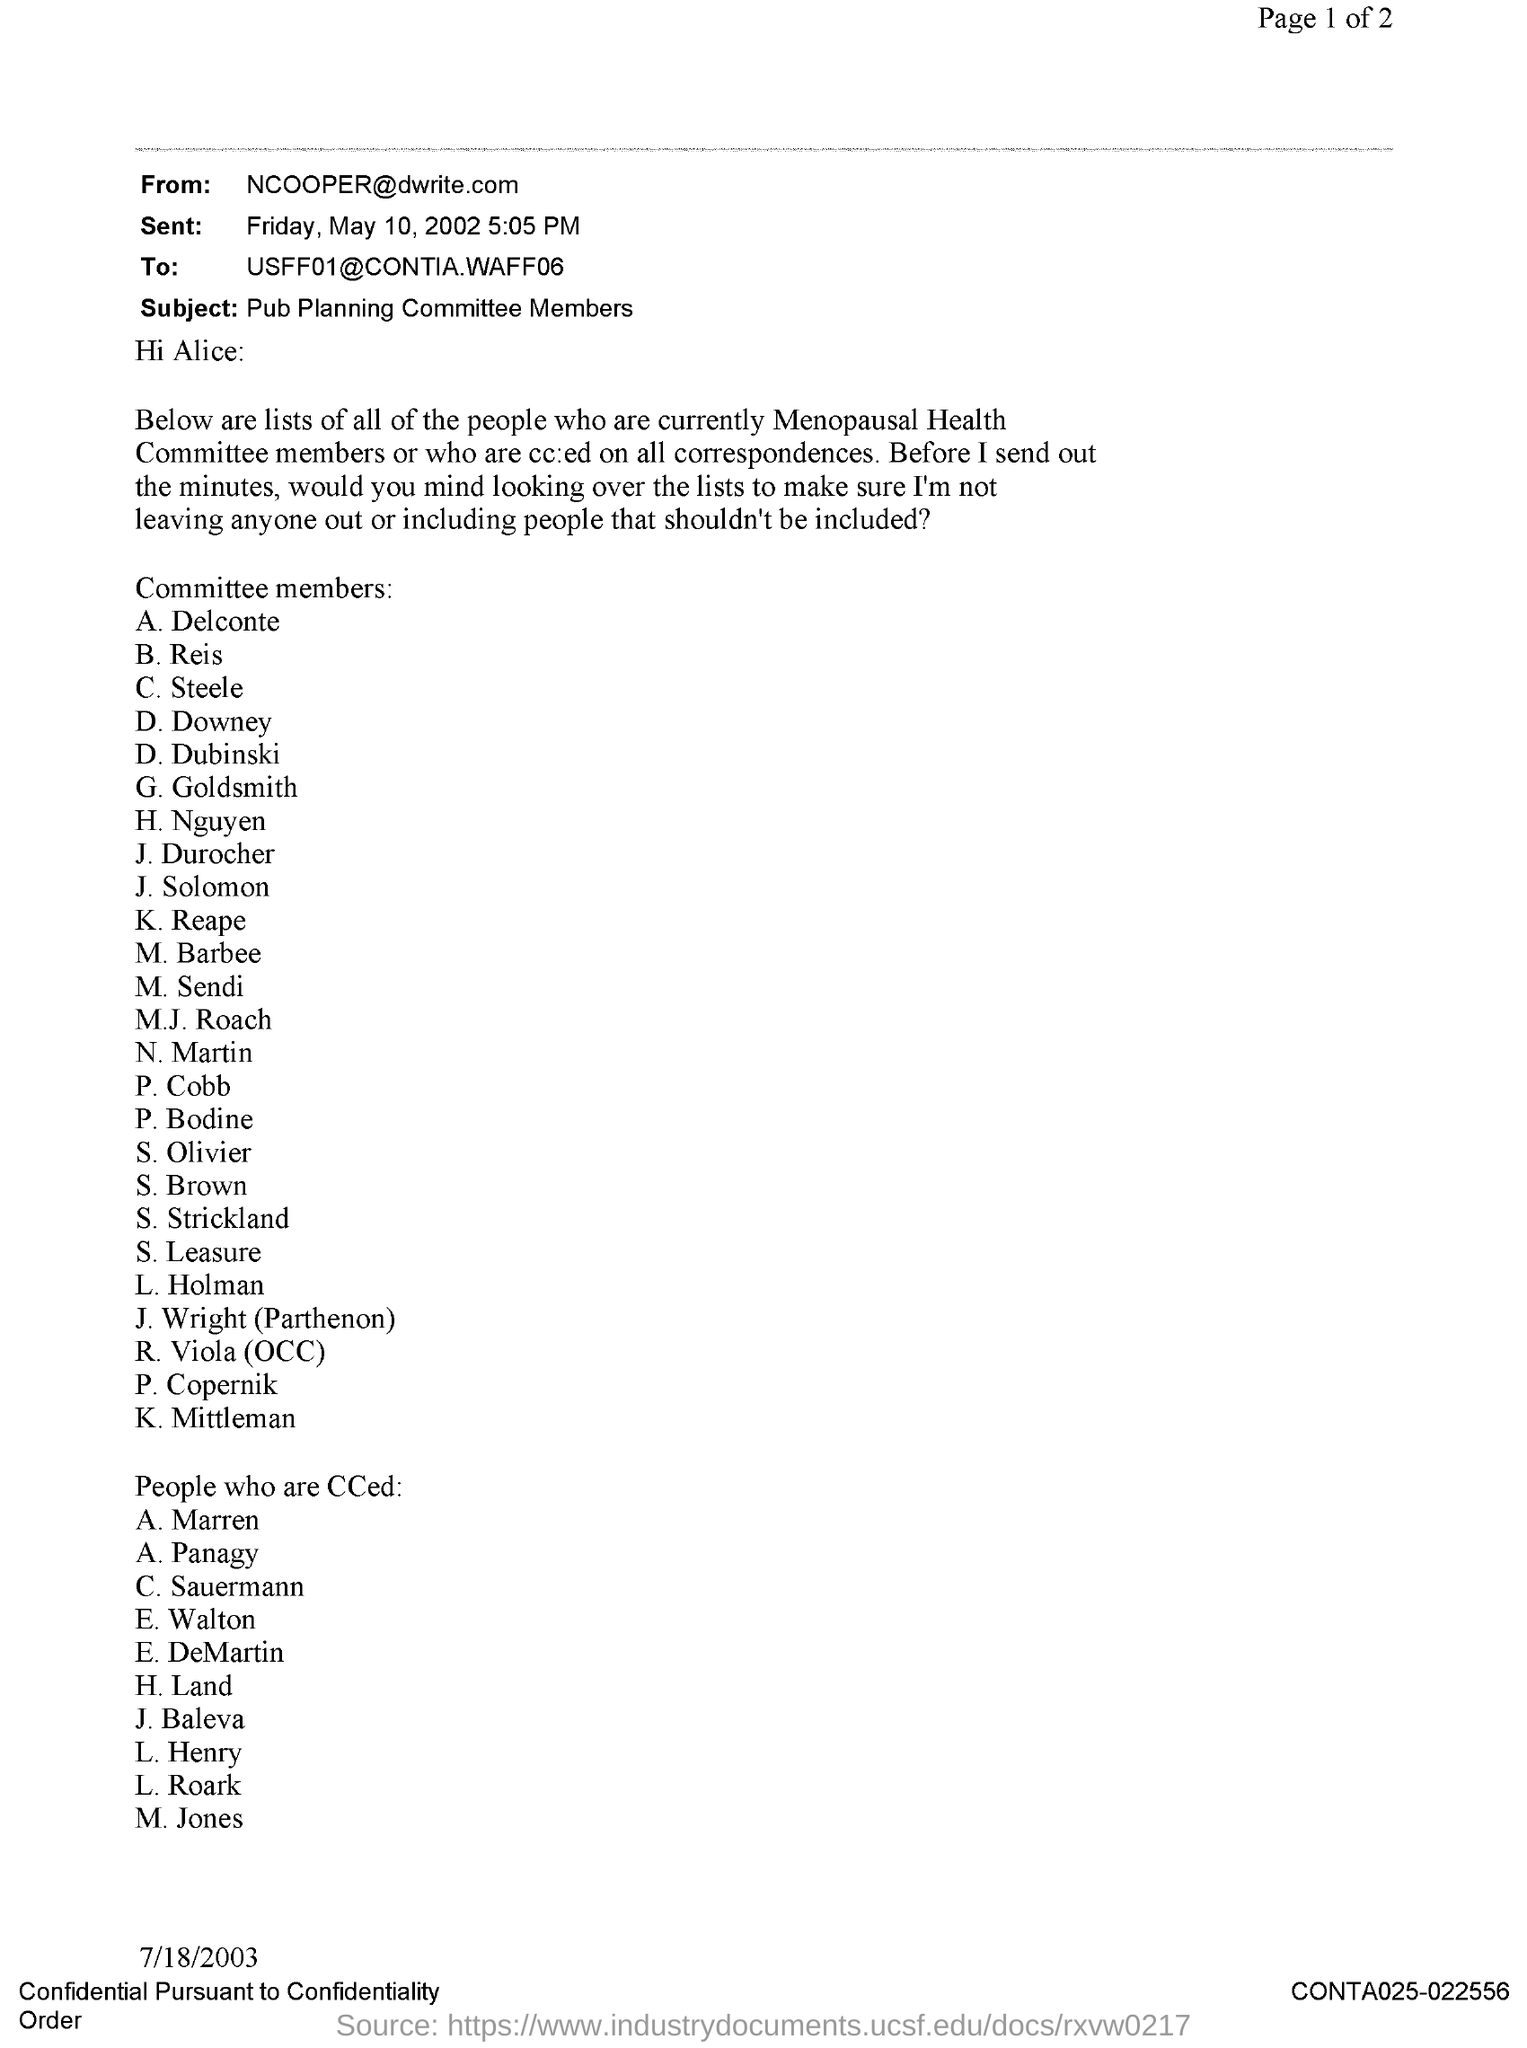Specify some key components in this picture. The subject of the sentence is "Pub Planning committee members. The document number is CONTA025-022556.... The sender of the email is NCOOPER@dwrite.com. The document is dated 7/18/2003. The message was sent on Friday, May 10, 2002 at 5:05 PM. 